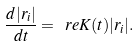<formula> <loc_0><loc_0><loc_500><loc_500>\frac { d | r _ { i } | } { d t } = \ r e K ( t ) | r _ { i } | .</formula> 